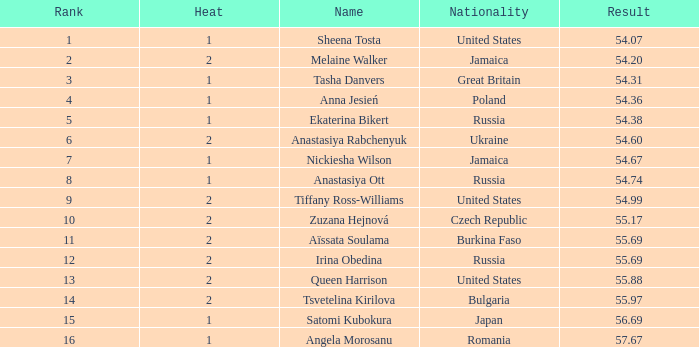In which rank does tsvetelina kirilova have a result smaller than 5 None. 